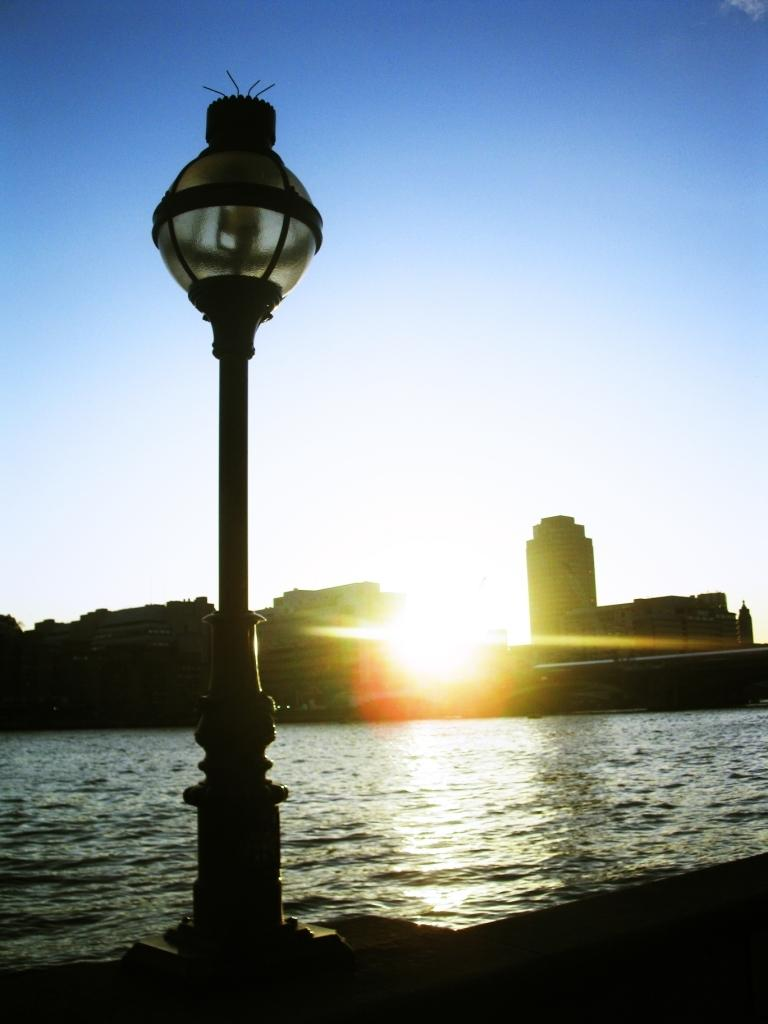What is the primary element visible in the image? There is water in the image. What structure can be seen in the image? There is a light pole in the image. What type of man-made structures are present in the image? There are buildings in the image. What can be seen in the distance in the image? The sky is visible in the background of the image. What class of animals can be seen swimming in the water in the image? There are no animals visible in the water in the image. 